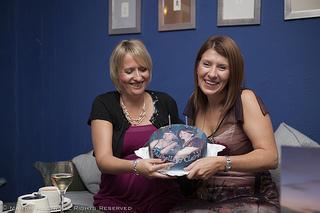How many people are there?
Give a very brief answer. 2. How many sandwiches have bites taken out of them?
Give a very brief answer. 0. 